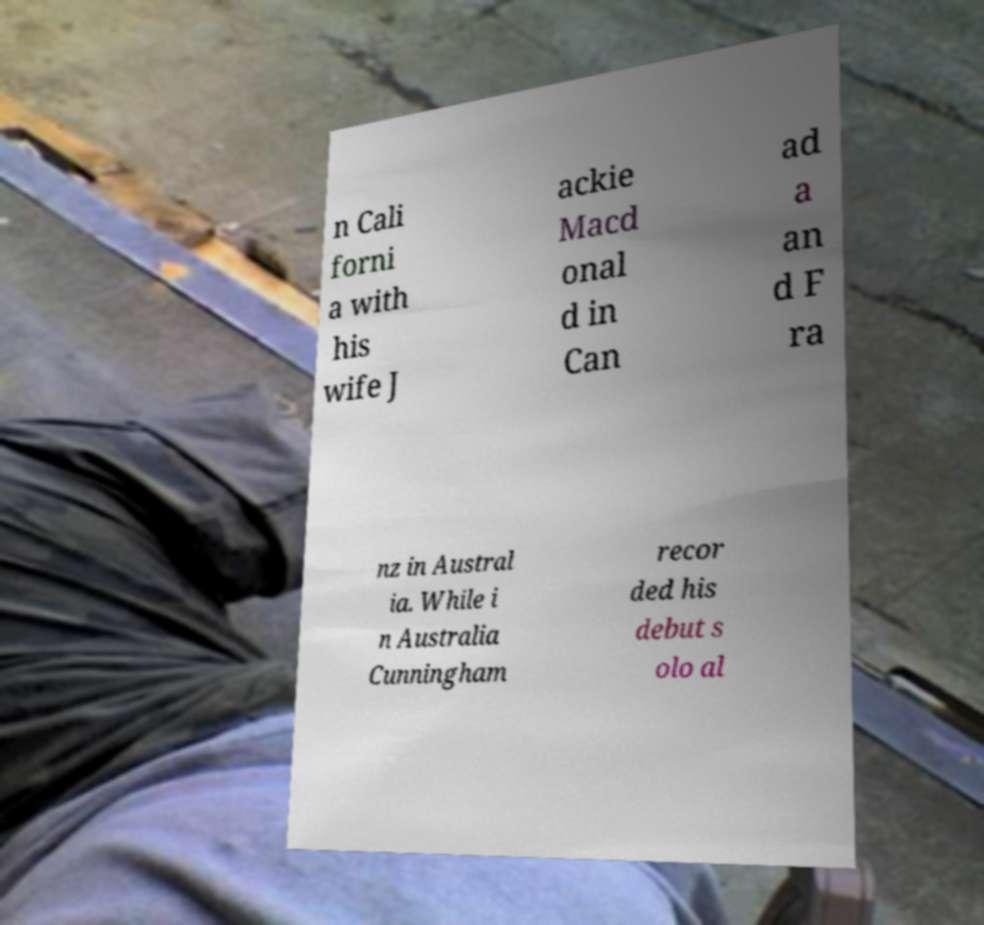There's text embedded in this image that I need extracted. Can you transcribe it verbatim? n Cali forni a with his wife J ackie Macd onal d in Can ad a an d F ra nz in Austral ia. While i n Australia Cunningham recor ded his debut s olo al 